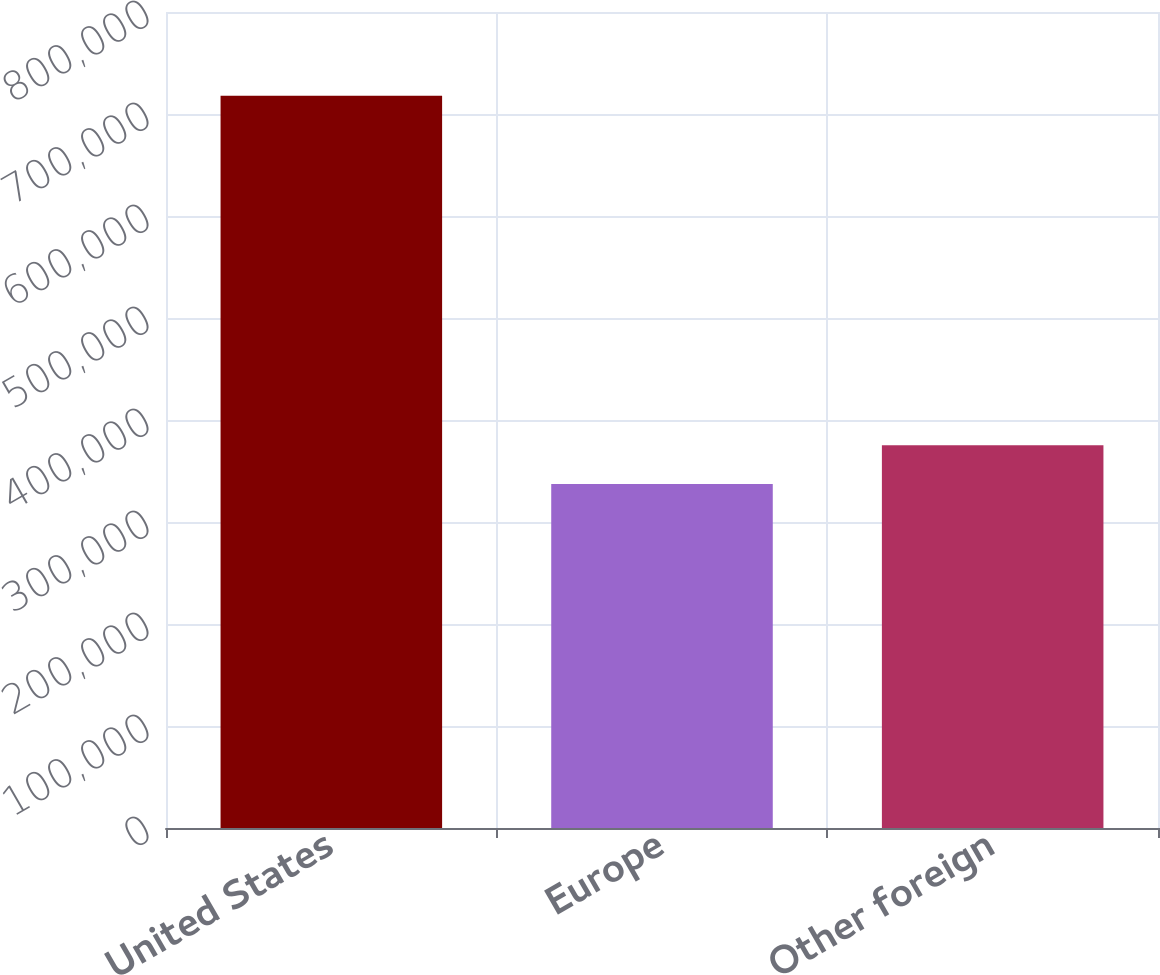<chart> <loc_0><loc_0><loc_500><loc_500><bar_chart><fcel>United States<fcel>Europe<fcel>Other foreign<nl><fcel>717841<fcel>337163<fcel>375231<nl></chart> 